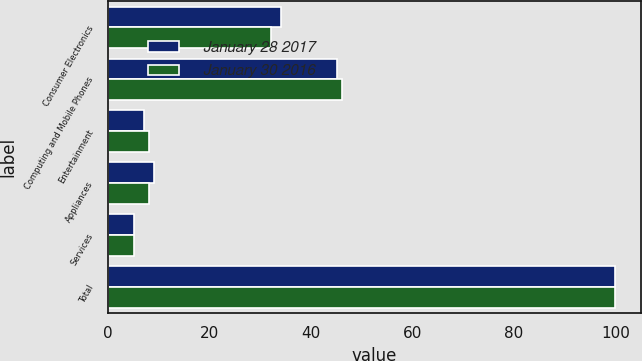Convert chart. <chart><loc_0><loc_0><loc_500><loc_500><stacked_bar_chart><ecel><fcel>Consumer Electronics<fcel>Computing and Mobile Phones<fcel>Entertainment<fcel>Appliances<fcel>Services<fcel>Total<nl><fcel>January 28 2017<fcel>34<fcel>45<fcel>7<fcel>9<fcel>5<fcel>100<nl><fcel>January 30 2016<fcel>32<fcel>46<fcel>8<fcel>8<fcel>5<fcel>100<nl></chart> 